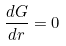<formula> <loc_0><loc_0><loc_500><loc_500>\frac { d G } { d r } = 0</formula> 